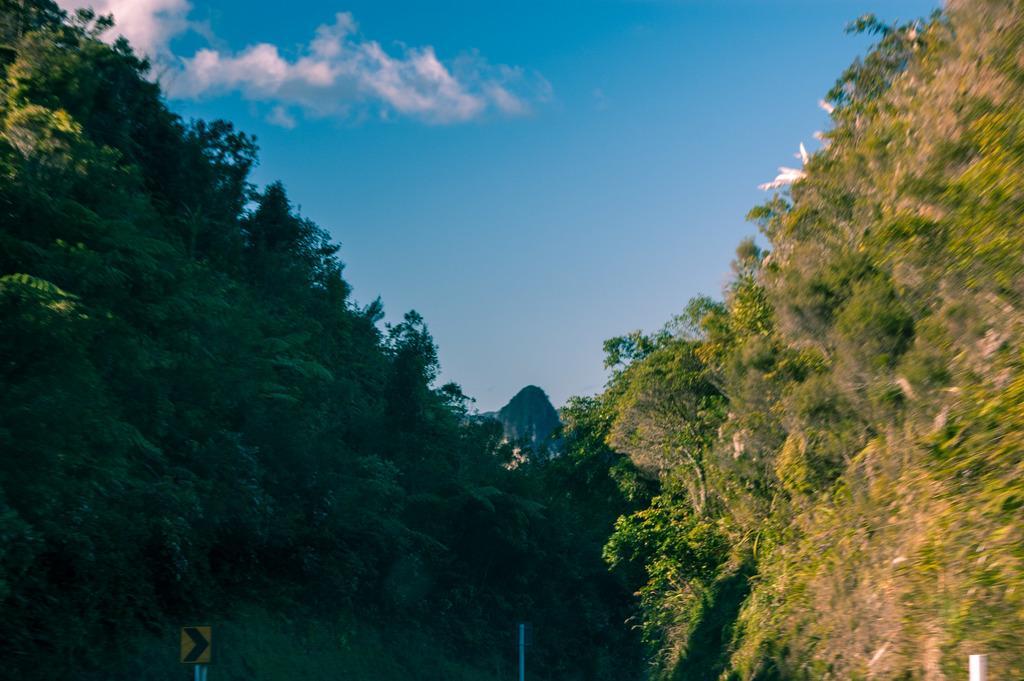Can you describe this image briefly? In this image there are mountains. There are trees on the mountains. In the center there is the sky. At the bottom there is a sign board. 